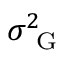<formula> <loc_0><loc_0><loc_500><loc_500>\sigma _ { G } ^ { 2 }</formula> 